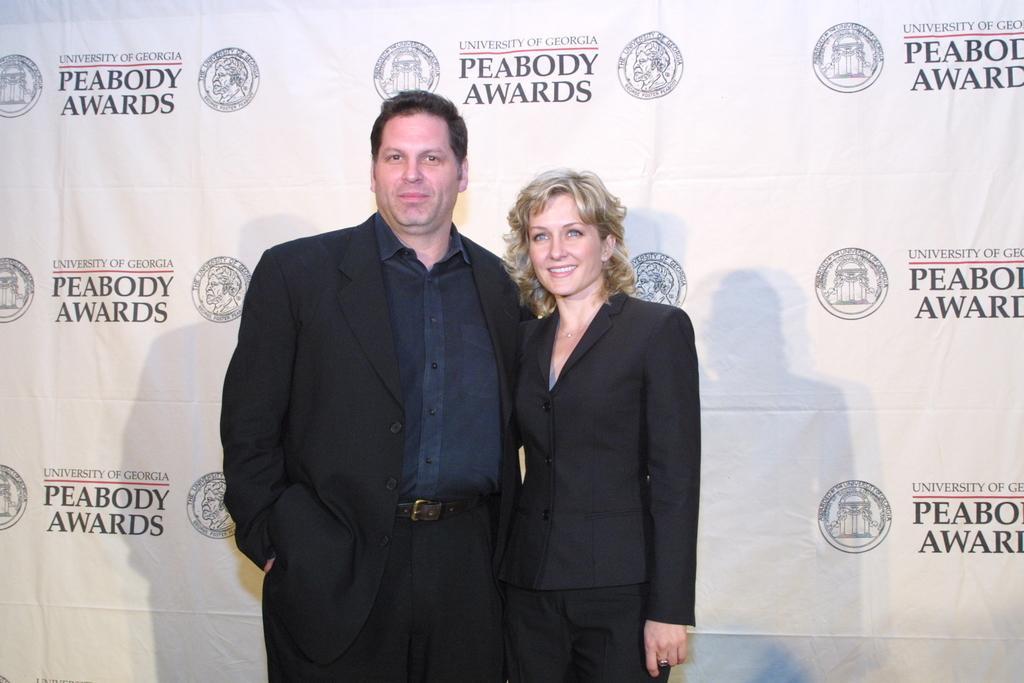How would you summarize this image in a sentence or two? There is a man in black color dress, smiling and standing near a woman who is in black color dress and is smiling and standing. In the background, there is a white color banner. 